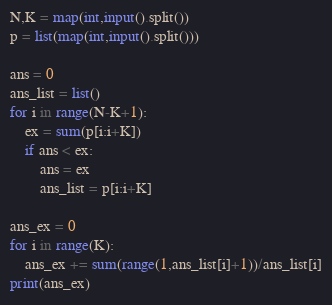<code> <loc_0><loc_0><loc_500><loc_500><_Python_>N,K = map(int,input().split())
p = list(map(int,input().split()))

ans = 0
ans_list = list()
for i in range(N-K+1):
	ex = sum(p[i:i+K])
	if ans < ex:	
		ans = ex
		ans_list = p[i:i+K]

ans_ex = 0
for i in range(K):
	ans_ex += sum(range(1,ans_list[i]+1))/ans_list[i]
print(ans_ex)</code> 